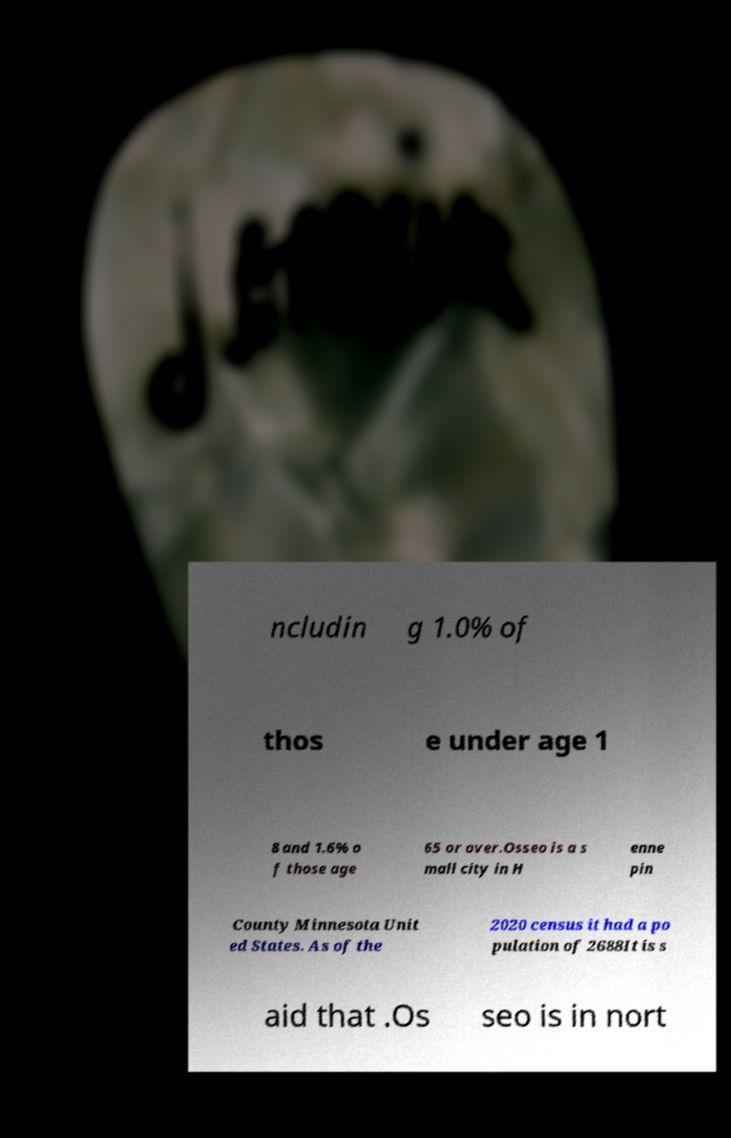What messages or text are displayed in this image? I need them in a readable, typed format. ncludin g 1.0% of thos e under age 1 8 and 1.6% o f those age 65 or over.Osseo is a s mall city in H enne pin County Minnesota Unit ed States. As of the 2020 census it had a po pulation of 2688It is s aid that .Os seo is in nort 